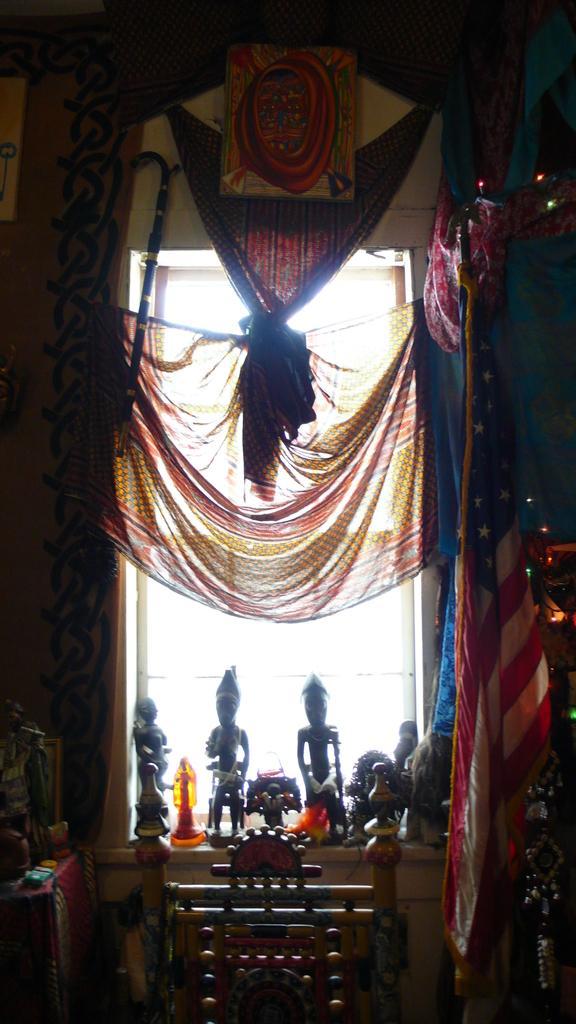Please provide a concise description of this image. In the foreground of this image, there are few cloths, curtains, few sculptures and it seems like a chair at the bottom. On the left, there is a wall. 